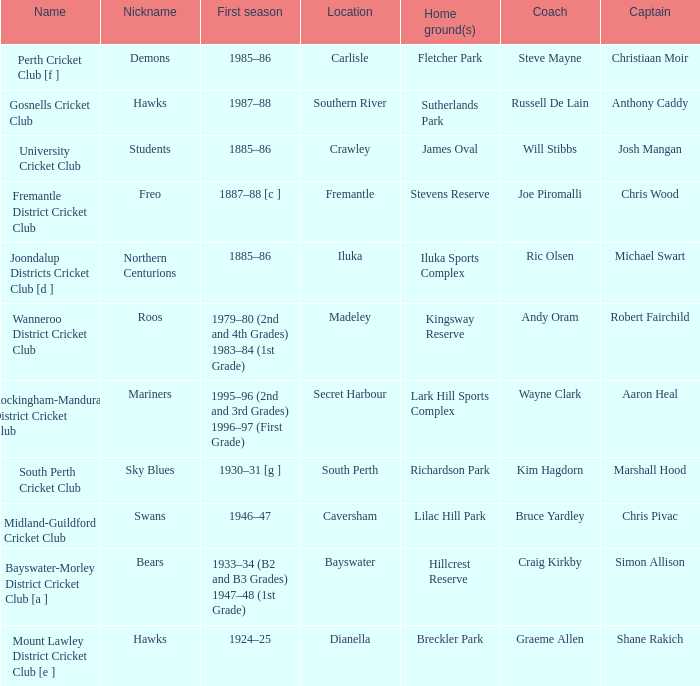Could you parse the entire table as a dict? {'header': ['Name', 'Nickname', 'First season', 'Location', 'Home ground(s)', 'Coach', 'Captain'], 'rows': [['Perth Cricket Club [f ]', 'Demons', '1985–86', 'Carlisle', 'Fletcher Park', 'Steve Mayne', 'Christiaan Moir'], ['Gosnells Cricket Club', 'Hawks', '1987–88', 'Southern River', 'Sutherlands Park', 'Russell De Lain', 'Anthony Caddy'], ['University Cricket Club', 'Students', '1885–86', 'Crawley', 'James Oval', 'Will Stibbs', 'Josh Mangan'], ['Fremantle District Cricket Club', 'Freo', '1887–88 [c ]', 'Fremantle', 'Stevens Reserve', 'Joe Piromalli', 'Chris Wood'], ['Joondalup Districts Cricket Club [d ]', 'Northern Centurions', '1885–86', 'Iluka', 'Iluka Sports Complex', 'Ric Olsen', 'Michael Swart'], ['Wanneroo District Cricket Club', 'Roos', '1979–80 (2nd and 4th Grades) 1983–84 (1st Grade)', 'Madeley', 'Kingsway Reserve', 'Andy Oram', 'Robert Fairchild'], ['Rockingham-Mandurah District Cricket Club', 'Mariners', '1995–96 (2nd and 3rd Grades) 1996–97 (First Grade)', 'Secret Harbour', 'Lark Hill Sports Complex', 'Wayne Clark', 'Aaron Heal'], ['South Perth Cricket Club', 'Sky Blues', '1930–31 [g ]', 'South Perth', 'Richardson Park', 'Kim Hagdorn', 'Marshall Hood'], ['Midland-Guildford Cricket Club', 'Swans', '1946–47', 'Caversham', 'Lilac Hill Park', 'Bruce Yardley', 'Chris Pivac'], ['Bayswater-Morley District Cricket Club [a ]', 'Bears', '1933–34 (B2 and B3 Grades) 1947–48 (1st Grade)', 'Bayswater', 'Hillcrest Reserve', 'Craig Kirkby', 'Simon Allison'], ['Mount Lawley District Cricket Club [e ]', 'Hawks', '1924–25', 'Dianella', 'Breckler Park', 'Graeme Allen', 'Shane Rakich']]} With the nickname the swans, what is the home ground? Lilac Hill Park. 